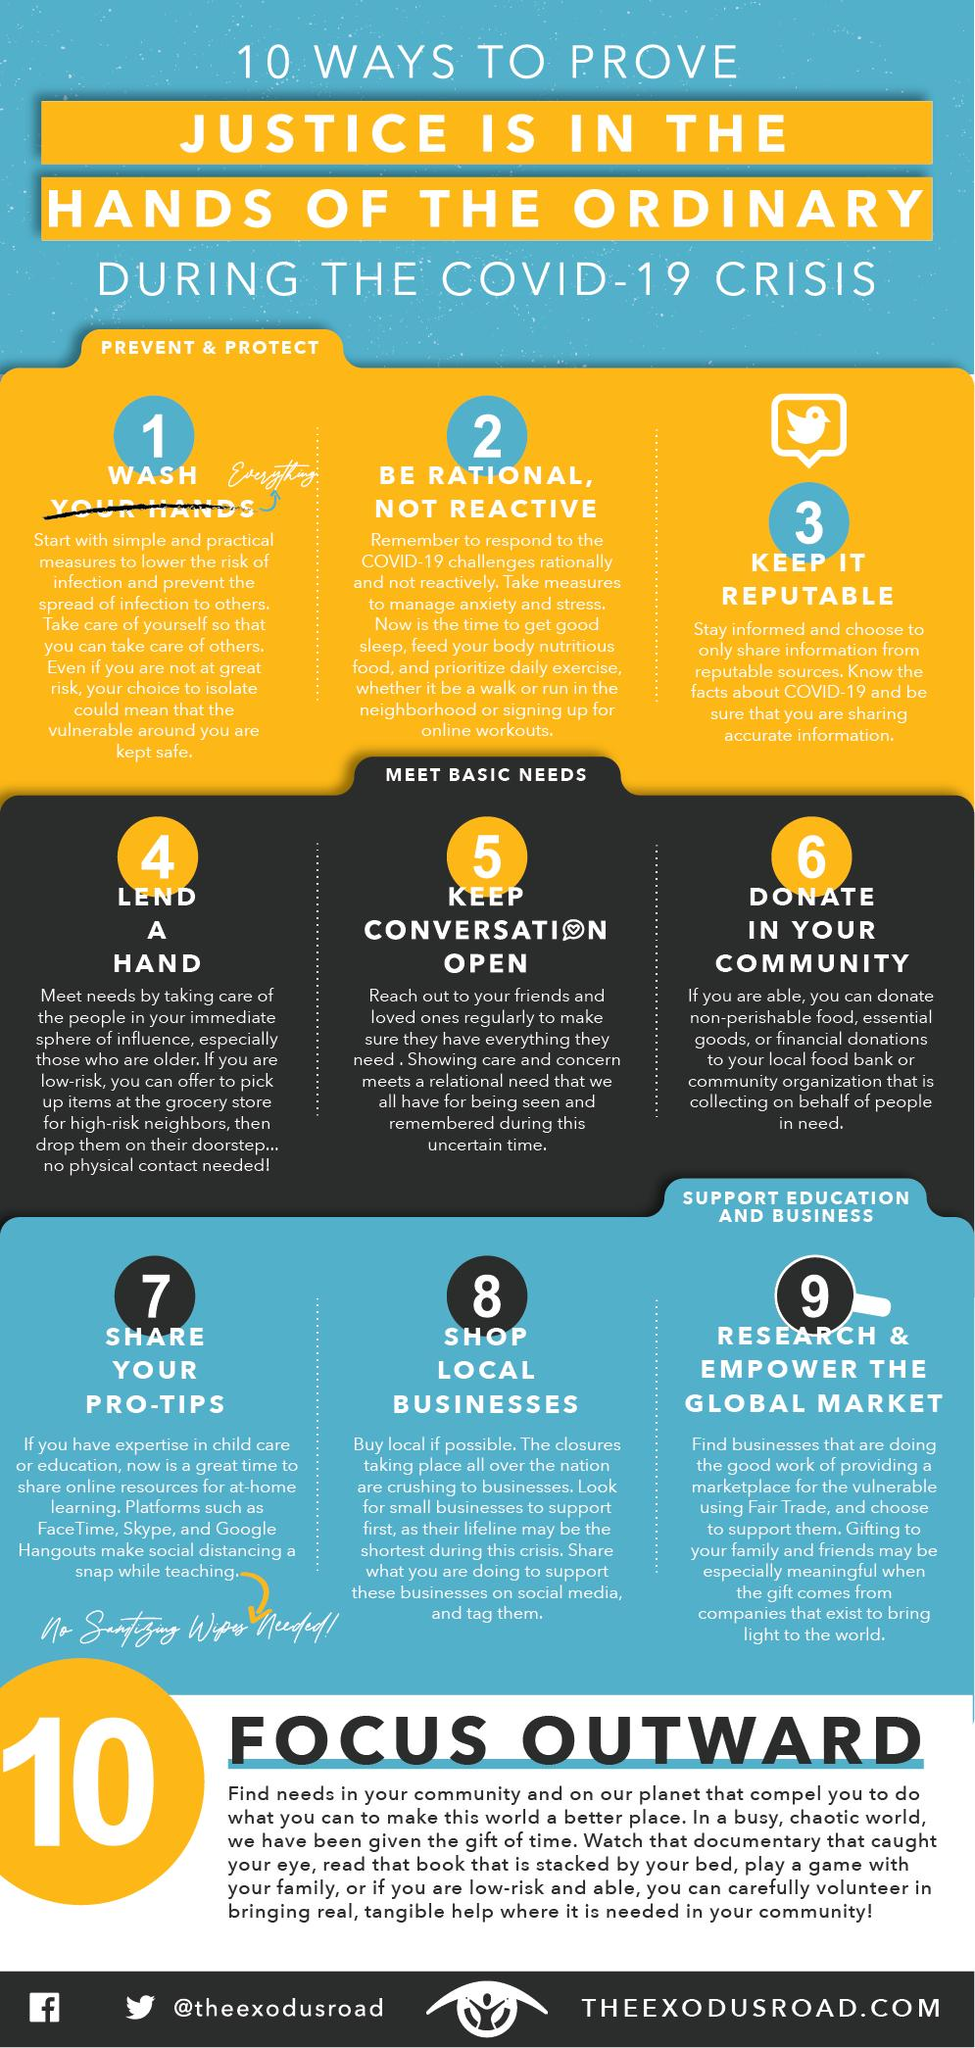Identify some key points in this picture. During times of crisis, it is important to support businesses that are most in need of assistance. Therefore, we should prioritize supporting local businesses over corporations and international businesses. One way to assist elderly neighbors is by providing grocery pick-up services. The use of FaceTime, Skype, and Google Hangouts can aid in teaching online by providing various applications that can assist in the teaching process. 